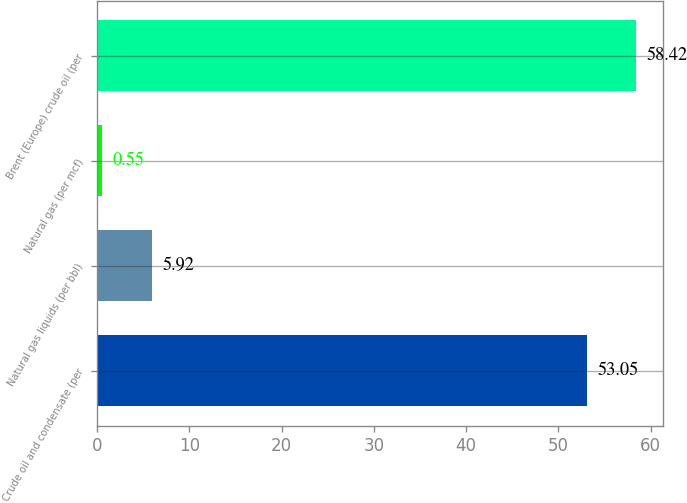Convert chart to OTSL. <chart><loc_0><loc_0><loc_500><loc_500><bar_chart><fcel>Crude oil and condensate (per<fcel>Natural gas liquids (per bbl)<fcel>Natural gas (per mcf)<fcel>Brent (Europe) crude oil (per<nl><fcel>53.05<fcel>5.92<fcel>0.55<fcel>58.42<nl></chart> 